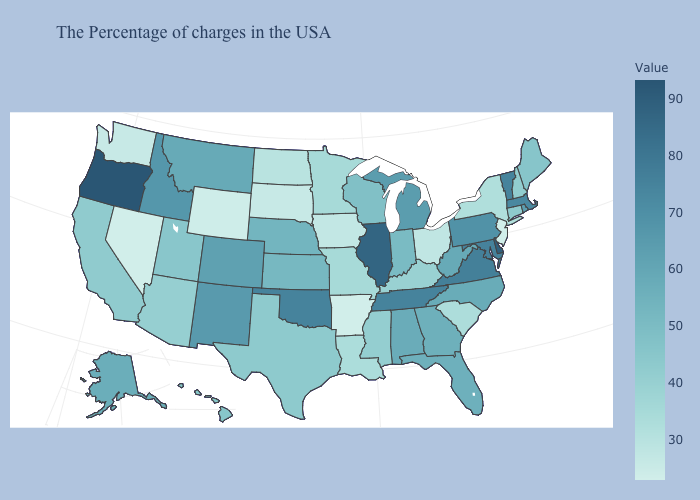Which states have the lowest value in the MidWest?
Write a very short answer. South Dakota. Which states have the lowest value in the MidWest?
Give a very brief answer. South Dakota. Does South Dakota have the lowest value in the MidWest?
Give a very brief answer. Yes. Among the states that border Virginia , which have the highest value?
Write a very short answer. Maryland. Does the map have missing data?
Write a very short answer. No. Among the states that border Colorado , does Arizona have the lowest value?
Quick response, please. No. Which states hav the highest value in the West?
Concise answer only. Oregon. 